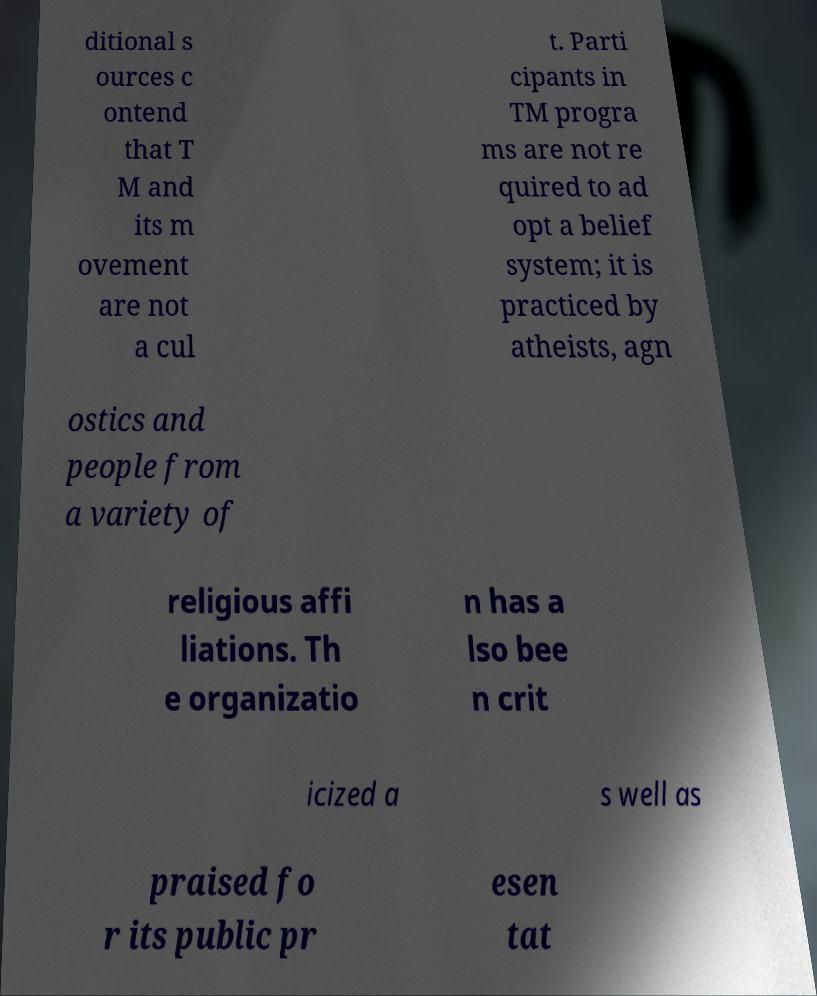Can you accurately transcribe the text from the provided image for me? ditional s ources c ontend that T M and its m ovement are not a cul t. Parti cipants in TM progra ms are not re quired to ad opt a belief system; it is practiced by atheists, agn ostics and people from a variety of religious affi liations. Th e organizatio n has a lso bee n crit icized a s well as praised fo r its public pr esen tat 